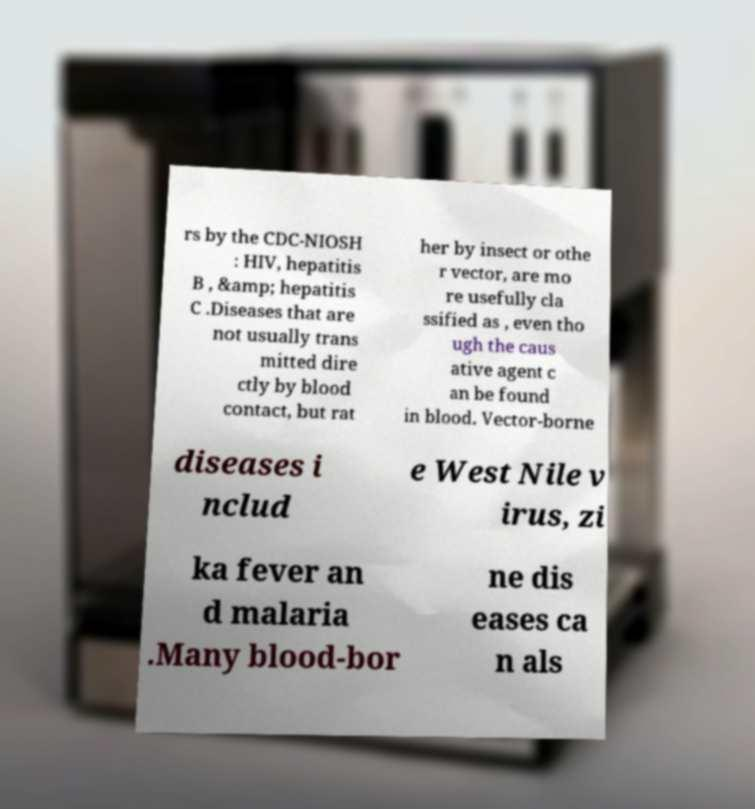Could you assist in decoding the text presented in this image and type it out clearly? rs by the CDC-NIOSH : HIV, hepatitis B , &amp; hepatitis C .Diseases that are not usually trans mitted dire ctly by blood contact, but rat her by insect or othe r vector, are mo re usefully cla ssified as , even tho ugh the caus ative agent c an be found in blood. Vector-borne diseases i nclud e West Nile v irus, zi ka fever an d malaria .Many blood-bor ne dis eases ca n als 